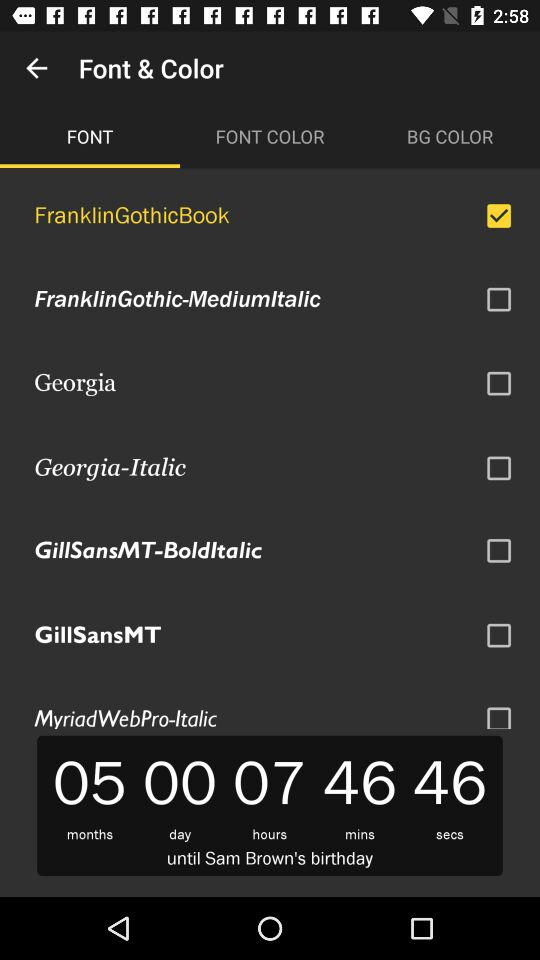What is the selected tab? The selected tab is "FONT". 